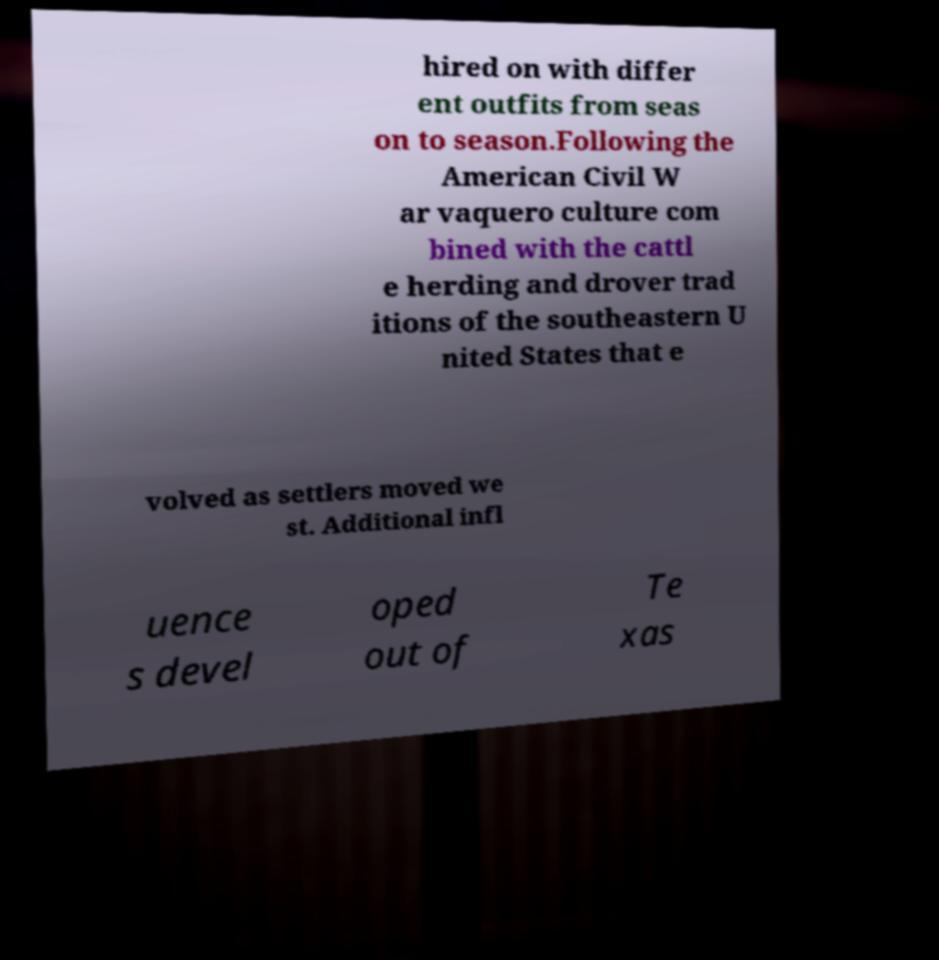Could you extract and type out the text from this image? hired on with differ ent outfits from seas on to season.Following the American Civil W ar vaquero culture com bined with the cattl e herding and drover trad itions of the southeastern U nited States that e volved as settlers moved we st. Additional infl uence s devel oped out of Te xas 